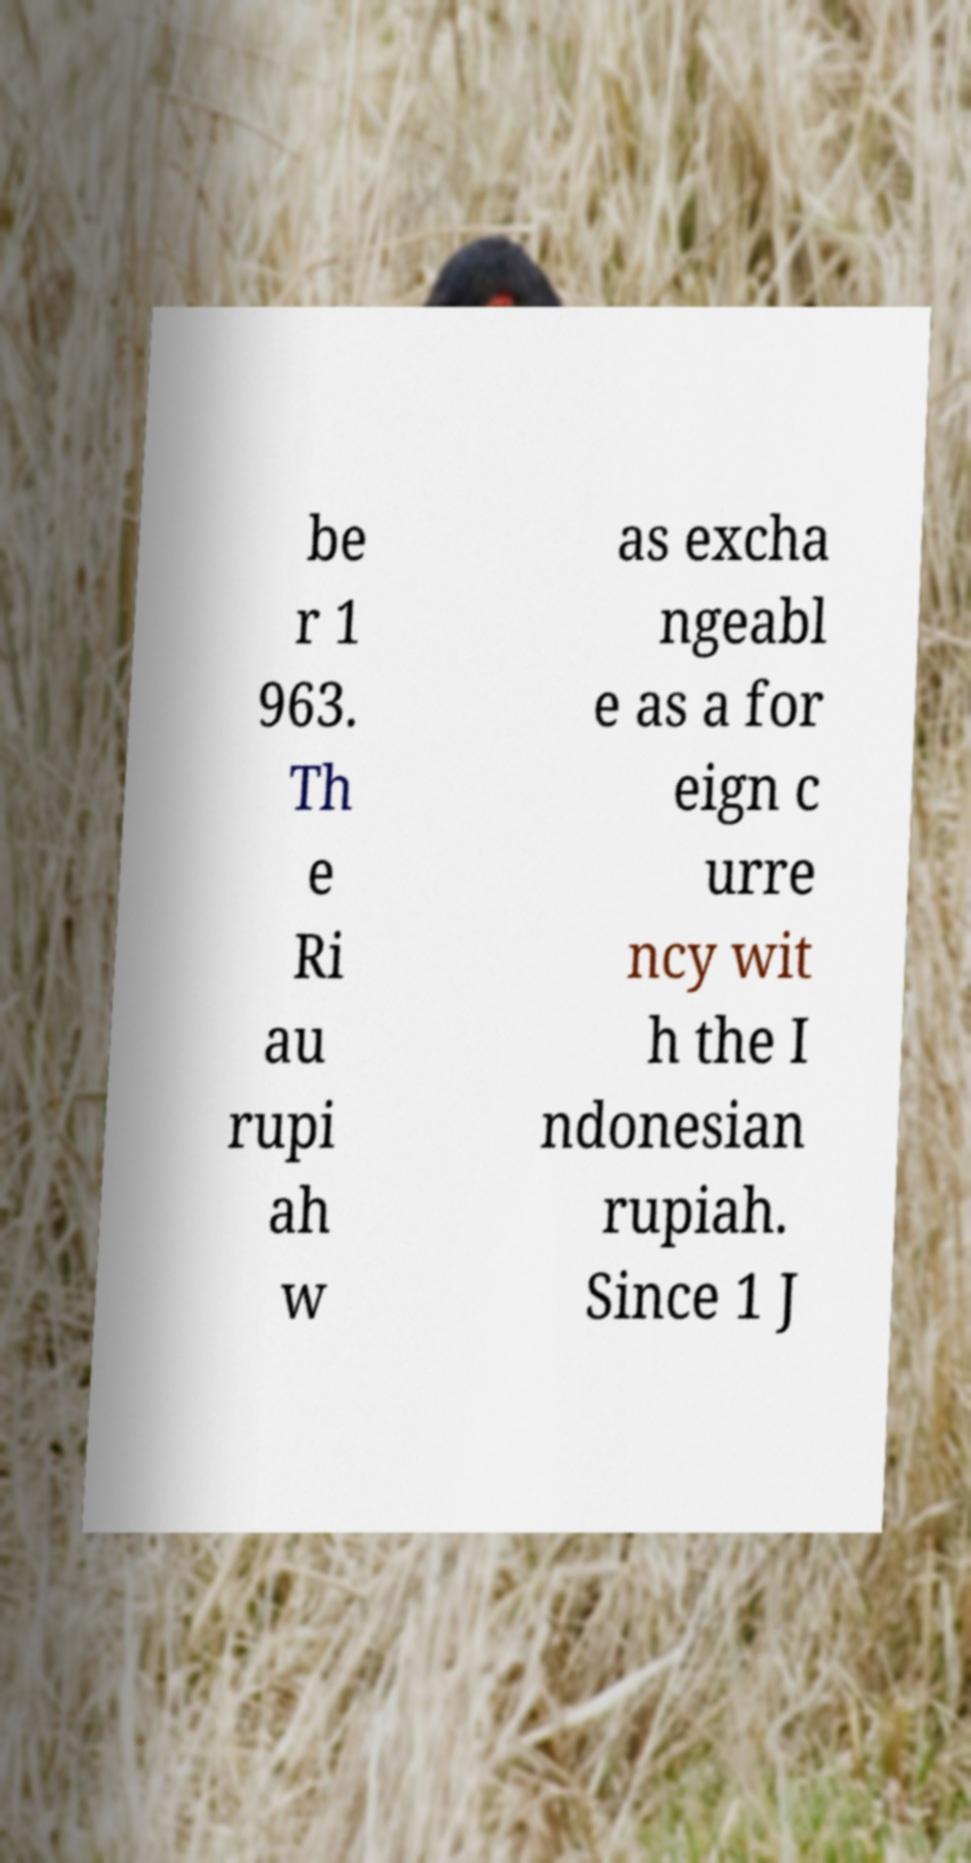Please identify and transcribe the text found in this image. be r 1 963. Th e Ri au rupi ah w as excha ngeabl e as a for eign c urre ncy wit h the I ndonesian rupiah. Since 1 J 